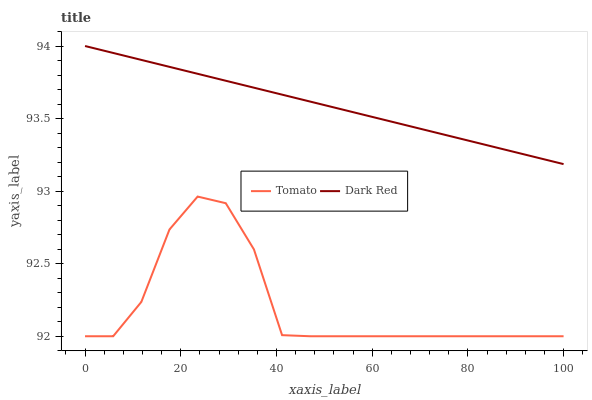Does Tomato have the minimum area under the curve?
Answer yes or no. Yes. Does Dark Red have the maximum area under the curve?
Answer yes or no. Yes. Does Dark Red have the minimum area under the curve?
Answer yes or no. No. Is Dark Red the smoothest?
Answer yes or no. Yes. Is Tomato the roughest?
Answer yes or no. Yes. Is Dark Red the roughest?
Answer yes or no. No. Does Tomato have the lowest value?
Answer yes or no. Yes. Does Dark Red have the lowest value?
Answer yes or no. No. Does Dark Red have the highest value?
Answer yes or no. Yes. Is Tomato less than Dark Red?
Answer yes or no. Yes. Is Dark Red greater than Tomato?
Answer yes or no. Yes. Does Tomato intersect Dark Red?
Answer yes or no. No. 